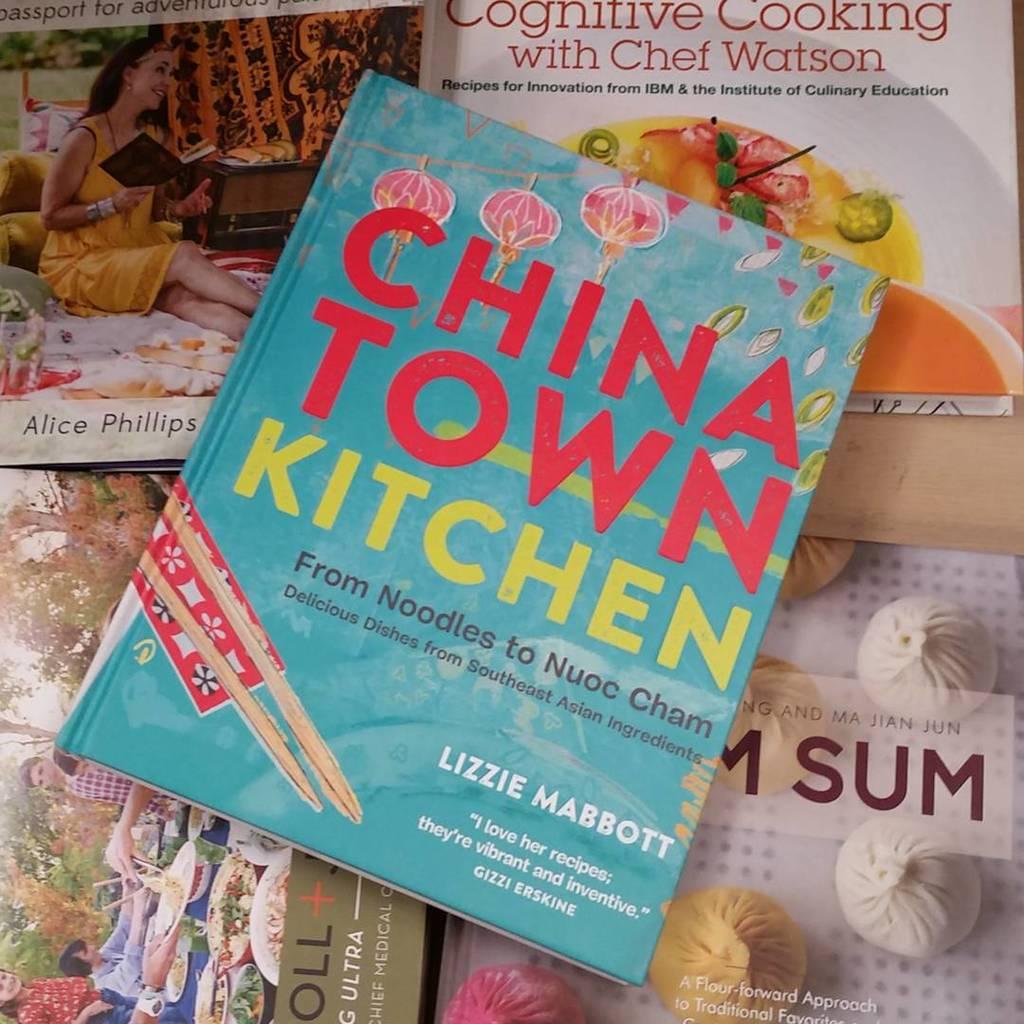<image>
Share a concise interpretation of the image provided. A book called China Town Kitchen has a bright blue color and includes noodle recipes. 